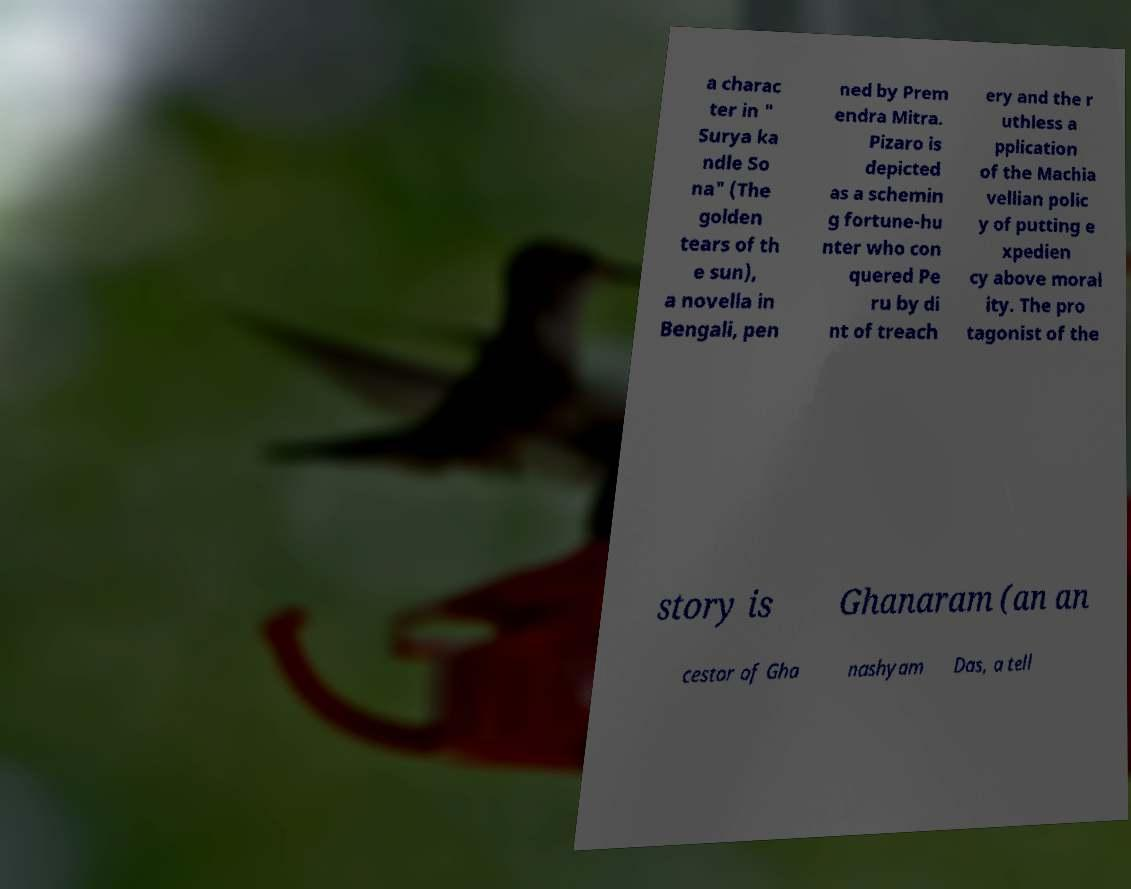Could you assist in decoding the text presented in this image and type it out clearly? a charac ter in " Surya ka ndle So na" (The golden tears of th e sun), a novella in Bengali, pen ned by Prem endra Mitra. Pizaro is depicted as a schemin g fortune-hu nter who con quered Pe ru by di nt of treach ery and the r uthless a pplication of the Machia vellian polic y of putting e xpedien cy above moral ity. The pro tagonist of the story is Ghanaram (an an cestor of Gha nashyam Das, a tell 